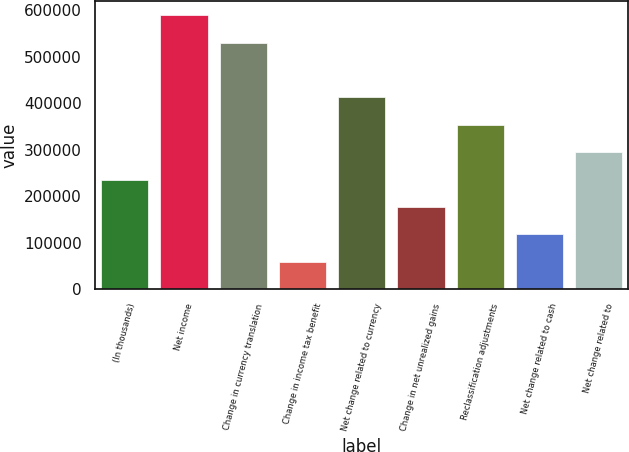Convert chart to OTSL. <chart><loc_0><loc_0><loc_500><loc_500><bar_chart><fcel>(In thousands)<fcel>Net income<fcel>Change in currency translation<fcel>Change in income tax benefit<fcel>Net change related to currency<fcel>Change in net unrealized gains<fcel>Reclassification adjustments<fcel>Net change related to cash<fcel>Net change related to<nl><fcel>236022<fcel>589130<fcel>530279<fcel>59468.3<fcel>412576<fcel>177171<fcel>353725<fcel>118320<fcel>294874<nl></chart> 